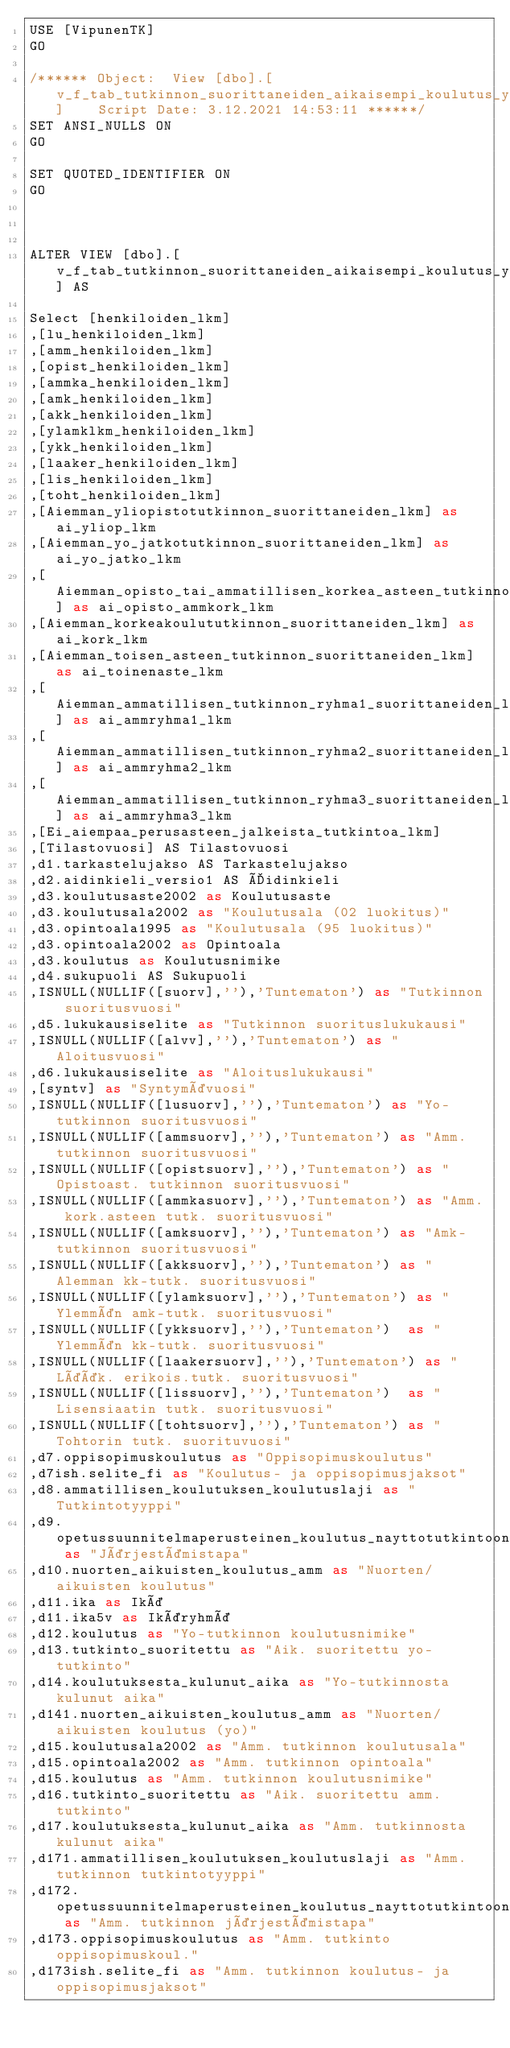<code> <loc_0><loc_0><loc_500><loc_500><_SQL_>USE [VipunenTK]
GO

/****** Object:  View [dbo].[v_f_tab_tutkinnon_suorittaneiden_aikaisempi_koulutus_yhteiset]    Script Date: 3.12.2021 14:53:11 ******/
SET ANSI_NULLS ON
GO

SET QUOTED_IDENTIFIER ON
GO



ALTER VIEW [dbo].[v_f_tab_tutkinnon_suorittaneiden_aikaisempi_koulutus_yhteiset] AS

Select [henkiloiden_lkm]
,[lu_henkiloiden_lkm]
,[amm_henkiloiden_lkm]
,[opist_henkiloiden_lkm]
,[ammka_henkiloiden_lkm]
,[amk_henkiloiden_lkm]
,[akk_henkiloiden_lkm]
,[ylamklkm_henkiloiden_lkm]
,[ykk_henkiloiden_lkm]
,[laaker_henkiloiden_lkm]
,[lis_henkiloiden_lkm]
,[toht_henkiloiden_lkm]
,[Aiemman_yliopistotutkinnon_suorittaneiden_lkm] as ai_yliop_lkm
,[Aiemman_yo_jatkotutkinnon_suorittaneiden_lkm] as ai_yo_jatko_lkm
,[Aiemman_opisto_tai_ammatillisen_korkea_asteen_tutkinnon_suorittaneiden_lkm] as ai_opisto_ammkork_lkm
,[Aiemman_korkeakoulututkinnon_suorittaneiden_lkm] as ai_kork_lkm
,[Aiemman_toisen_asteen_tutkinnon_suorittaneiden_lkm] as ai_toinenaste_lkm
,[Aiemman_ammatillisen_tutkinnon_ryhma1_suorittaneiden_lkm] as ai_ammryhma1_lkm
,[Aiemman_ammatillisen_tutkinnon_ryhma2_suorittaneiden_lkm] as ai_ammryhma2_lkm
,[Aiemman_ammatillisen_tutkinnon_ryhma3_suorittaneiden_lkm] as ai_ammryhma3_lkm
,[Ei_aiempaa_perusasteen_jalkeista_tutkintoa_lkm]
,[Tilastovuosi] AS Tilastovuosi
,d1.tarkastelujakso AS Tarkastelujakso
,d2.aidinkieli_versio1 AS Äidinkieli
,d3.koulutusaste2002 as Koulutusaste
,d3.koulutusala2002 as "Koulutusala (02 luokitus)"
,d3.opintoala1995 as "Koulutusala (95 luokitus)"
,d3.opintoala2002 as Opintoala
,d3.koulutus as Koulutusnimike
,d4.sukupuoli AS Sukupuoli
,ISNULL(NULLIF([suorv],''),'Tuntematon') as "Tutkinnon suoritusvuosi"
,d5.lukukausiselite as "Tutkinnon suorituslukukausi"
,ISNULL(NULLIF([alvv],''),'Tuntematon') as "Aloitusvuosi"
,d6.lukukausiselite as "Aloituslukukausi"
,[syntv] as "Syntymävuosi"
,ISNULL(NULLIF([lusuorv],''),'Tuntematon') as "Yo-tutkinnon suoritusvuosi"
,ISNULL(NULLIF([ammsuorv],''),'Tuntematon') as "Amm. tutkinnon suoritusvuosi"
,ISNULL(NULLIF([opistsuorv],''),'Tuntematon') as "Opistoast. tutkinnon suoritusvuosi"
,ISNULL(NULLIF([ammkasuorv],''),'Tuntematon') as "Amm. kork.asteen tutk. suoritusvuosi"
,ISNULL(NULLIF([amksuorv],''),'Tuntematon') as "Amk-tutkinnon suoritusvuosi"
,ISNULL(NULLIF([akksuorv],''),'Tuntematon') as "Alemman kk-tutk. suoritusvuosi"
,ISNULL(NULLIF([ylamksuorv],''),'Tuntematon') as "Ylemmän amk-tutk. suoritusvuosi"
,ISNULL(NULLIF([ykksuorv],''),'Tuntematon')  as "Ylemmän kk-tutk. suoritusvuosi"
,ISNULL(NULLIF([laakersuorv],''),'Tuntematon') as "Lääk. erikois.tutk. suoritusvuosi"
,ISNULL(NULLIF([lissuorv],''),'Tuntematon')  as "Lisensiaatin tutk. suoritusvuosi"
,ISNULL(NULLIF([tohtsuorv],''),'Tuntematon') as "Tohtorin tutk. suorituvuosi"
,d7.oppisopimuskoulutus as "Oppisopimuskoulutus"
,d7ish.selite_fi as "Koulutus- ja oppisopimusjaksot"
,d8.ammatillisen_koulutuksen_koulutuslaji as "Tutkintotyyppi"
,d9.opetussuunnitelmaperusteinen_koulutus_nayttotutkintoon_valmistava_koulutus as "Järjestämistapa"
,d10.nuorten_aikuisten_koulutus_amm as "Nuorten/aikuisten koulutus"
,d11.ika as Ikä
,d11.ika5v as Ikäryhmä
,d12.koulutus as "Yo-tutkinnon koulutusnimike"
,d13.tutkinto_suoritettu as "Aik. suoritettu yo-tutkinto"
,d14.koulutuksesta_kulunut_aika as "Yo-tutkinnosta kulunut aika"
,d141.nuorten_aikuisten_koulutus_amm as "Nuorten/aikuisten koulutus (yo)"
,d15.koulutusala2002 as "Amm. tutkinnon koulutusala"
,d15.opintoala2002 as "Amm. tutkinnon opintoala"
,d15.koulutus as "Amm. tutkinnon koulutusnimike"
,d16.tutkinto_suoritettu as "Aik. suoritettu amm. tutkinto"
,d17.koulutuksesta_kulunut_aika as "Amm. tutkinnosta kulunut aika"
,d171.ammatillisen_koulutuksen_koulutuslaji as "Amm. tutkinnon tutkintotyyppi"
,d172.opetussuunnitelmaperusteinen_koulutus_nayttotutkintoon_valmistava_koulutus as "Amm. tutkinnon järjestämistapa"
,d173.oppisopimuskoulutus as "Amm. tutkinto oppisopimuskoul."
,d173ish.selite_fi as "Amm. tutkinnon koulutus- ja oppisopimusjaksot"</code> 